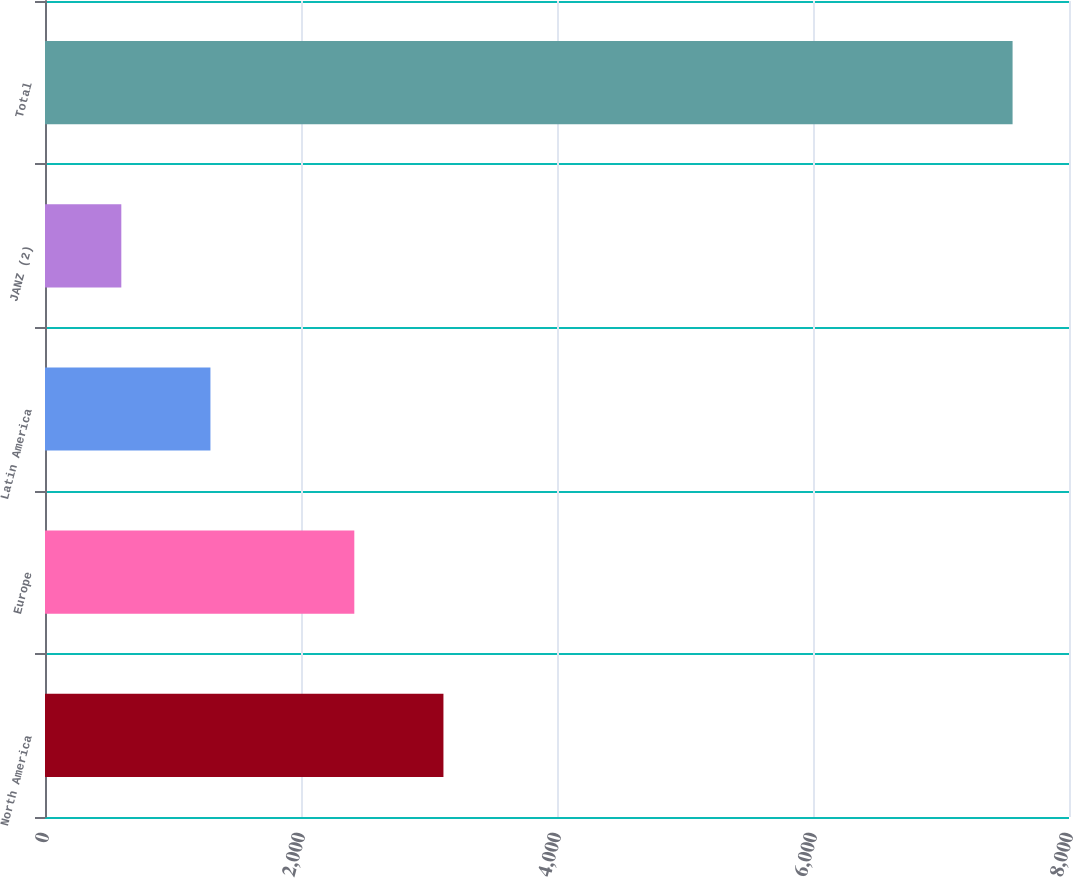Convert chart to OTSL. <chart><loc_0><loc_0><loc_500><loc_500><bar_chart><fcel>North America<fcel>Europe<fcel>Latin America<fcel>JANZ (2)<fcel>Total<nl><fcel>3112.8<fcel>2416.5<fcel>1292.5<fcel>596.2<fcel>7559.2<nl></chart> 